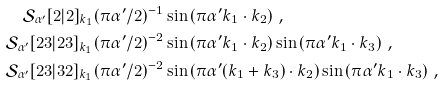Convert formula to latex. <formula><loc_0><loc_0><loc_500><loc_500>\mathcal { S } _ { \alpha ^ { \prime } } [ 2 | 2 ] _ { k _ { 1 } } & ( \pi \alpha ^ { \prime } / 2 ) ^ { - 1 } \sin \left ( \pi \alpha ^ { \prime } k _ { 1 } \cdot k _ { 2 } \right ) \, , \\ \mathcal { S } _ { \alpha ^ { \prime } } [ 2 3 | 2 3 ] _ { k _ { 1 } } & ( \pi \alpha ^ { \prime } / 2 ) ^ { - 2 } \sin \left ( \pi \alpha ^ { \prime } k _ { 1 } \cdot k _ { 2 } \right ) \sin \left ( \pi \alpha ^ { \prime } k _ { 1 } \cdot k _ { 3 } \right ) \, , \\ \mathcal { S } _ { \alpha ^ { \prime } } [ 2 3 | 3 2 ] _ { k _ { 1 } } & ( \pi \alpha ^ { \prime } / 2 ) ^ { - 2 } \sin \left ( \pi \alpha ^ { \prime } ( k _ { 1 } + k _ { 3 } ) \cdot k _ { 2 } \right ) \sin \left ( \pi \alpha ^ { \prime } k _ { 1 } \cdot k _ { 3 } \right ) \, ,</formula> 